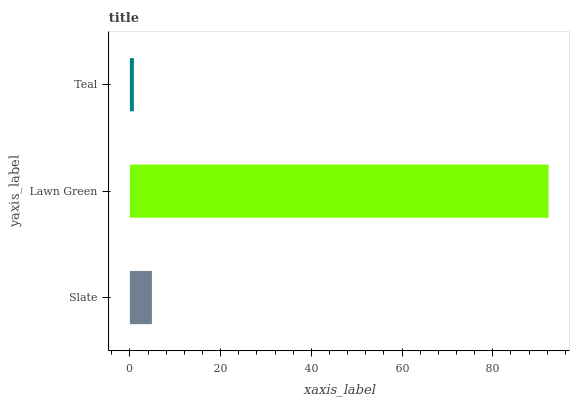Is Teal the minimum?
Answer yes or no. Yes. Is Lawn Green the maximum?
Answer yes or no. Yes. Is Lawn Green the minimum?
Answer yes or no. No. Is Teal the maximum?
Answer yes or no. No. Is Lawn Green greater than Teal?
Answer yes or no. Yes. Is Teal less than Lawn Green?
Answer yes or no. Yes. Is Teal greater than Lawn Green?
Answer yes or no. No. Is Lawn Green less than Teal?
Answer yes or no. No. Is Slate the high median?
Answer yes or no. Yes. Is Slate the low median?
Answer yes or no. Yes. Is Teal the high median?
Answer yes or no. No. Is Teal the low median?
Answer yes or no. No. 